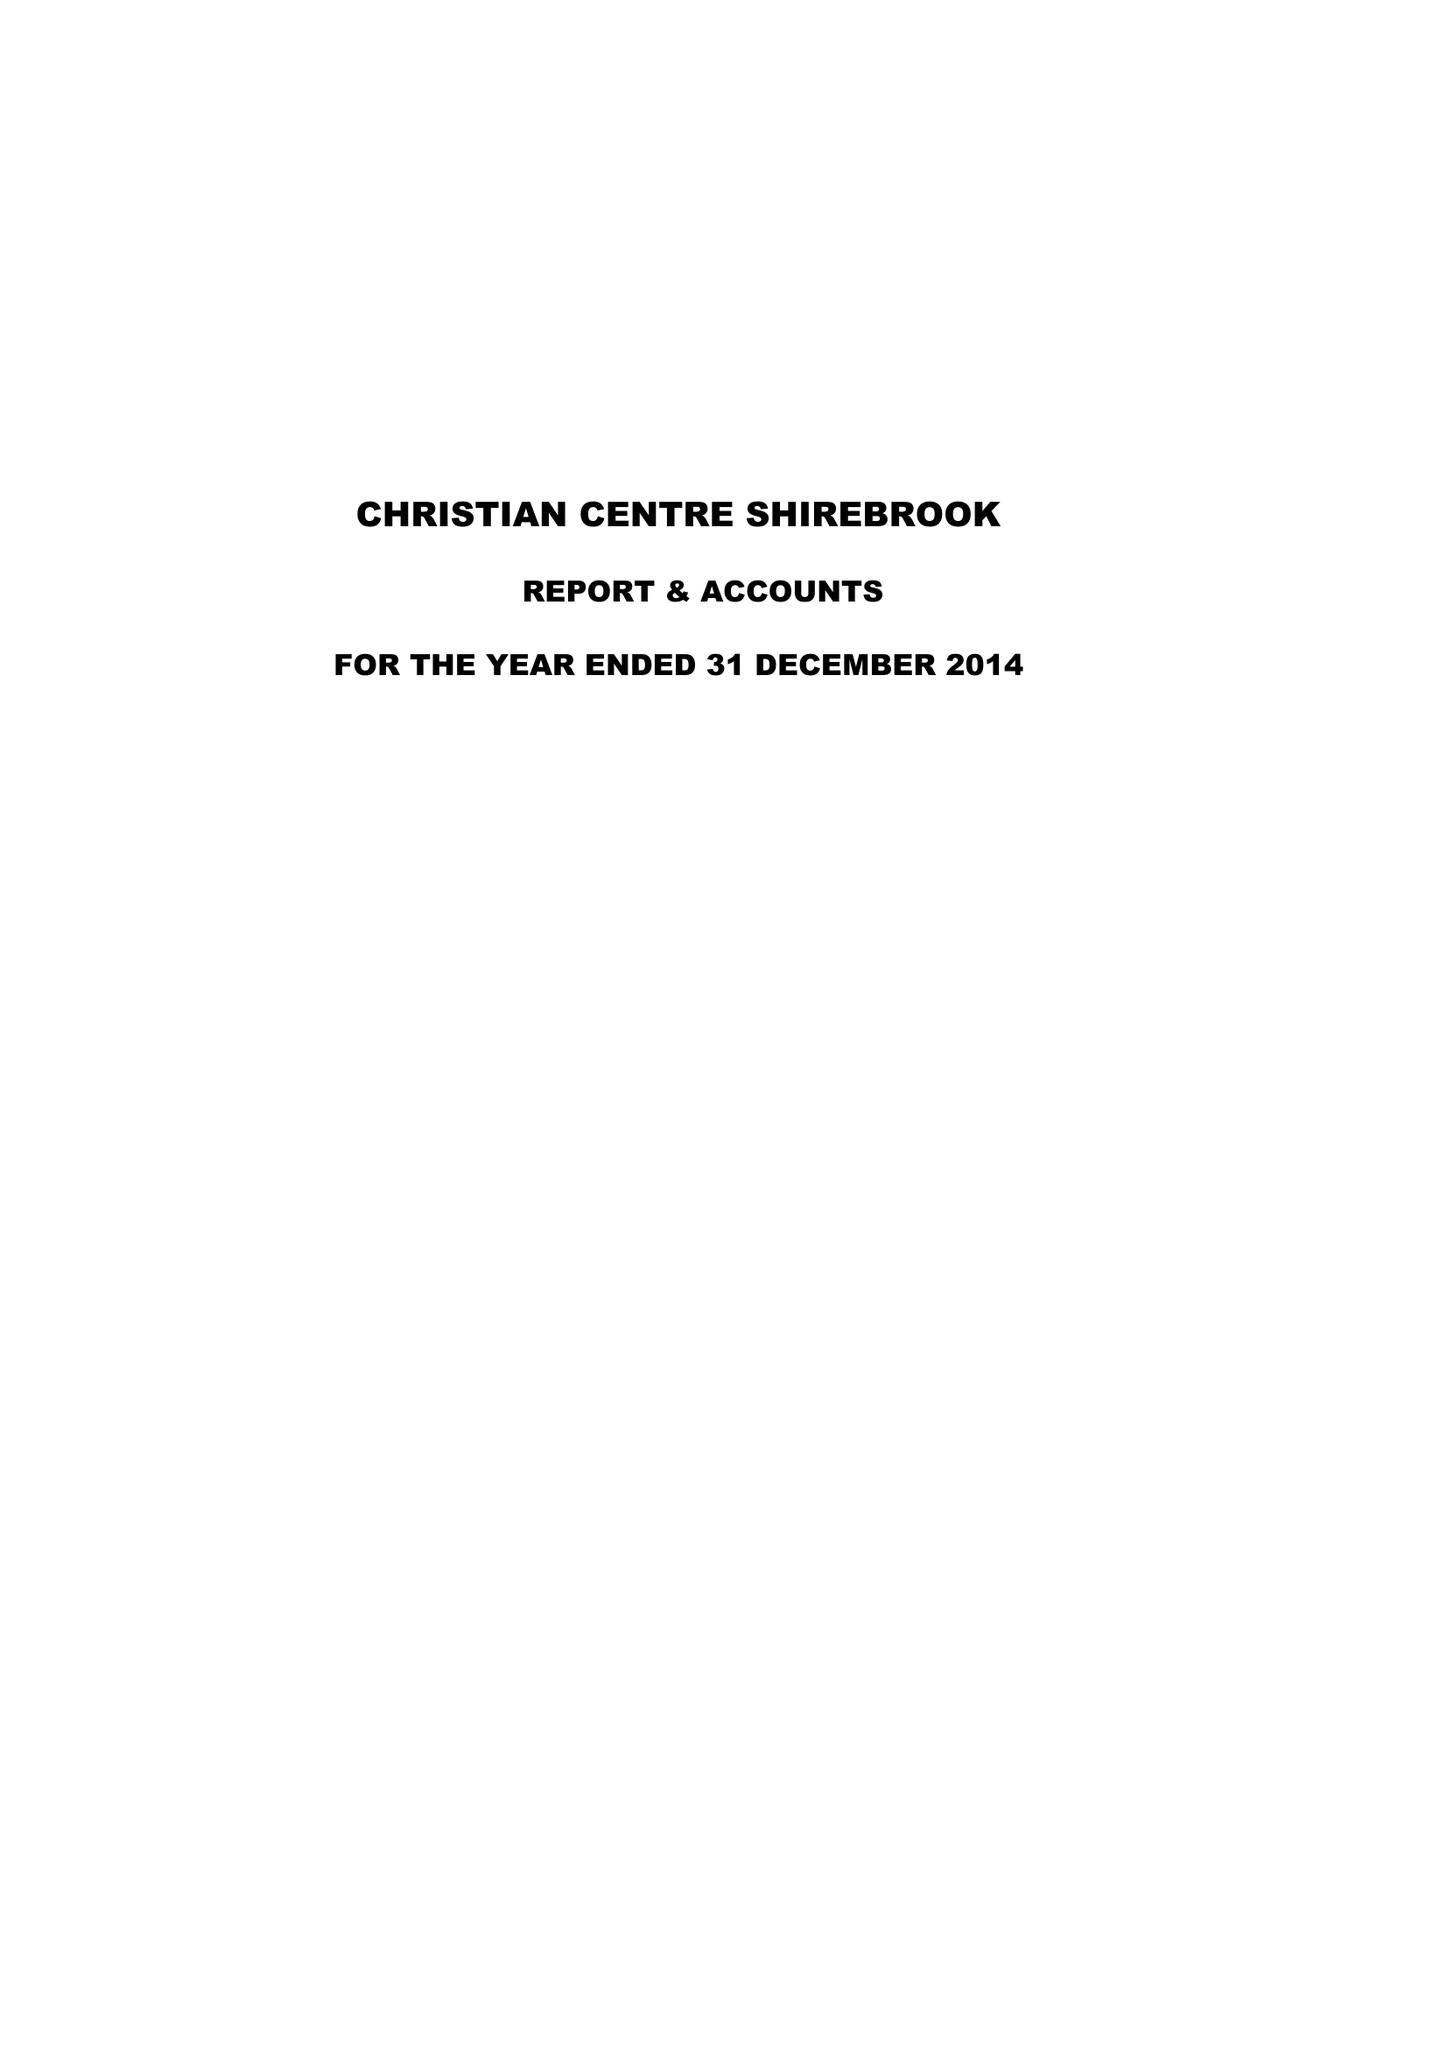What is the value for the income_annually_in_british_pounds?
Answer the question using a single word or phrase. 88572.00 